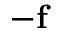Convert formula to latex. <formula><loc_0><loc_0><loc_500><loc_500>- f</formula> 